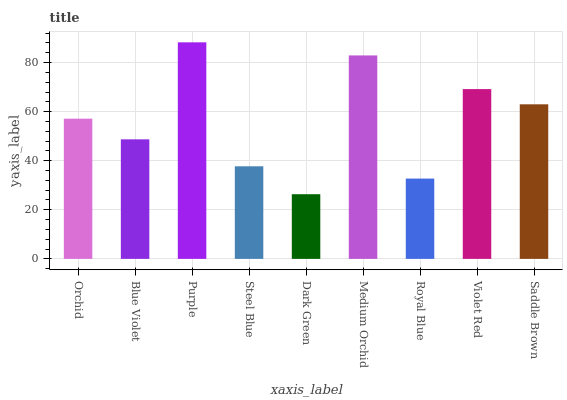Is Blue Violet the minimum?
Answer yes or no. No. Is Blue Violet the maximum?
Answer yes or no. No. Is Orchid greater than Blue Violet?
Answer yes or no. Yes. Is Blue Violet less than Orchid?
Answer yes or no. Yes. Is Blue Violet greater than Orchid?
Answer yes or no. No. Is Orchid less than Blue Violet?
Answer yes or no. No. Is Orchid the high median?
Answer yes or no. Yes. Is Orchid the low median?
Answer yes or no. Yes. Is Dark Green the high median?
Answer yes or no. No. Is Medium Orchid the low median?
Answer yes or no. No. 